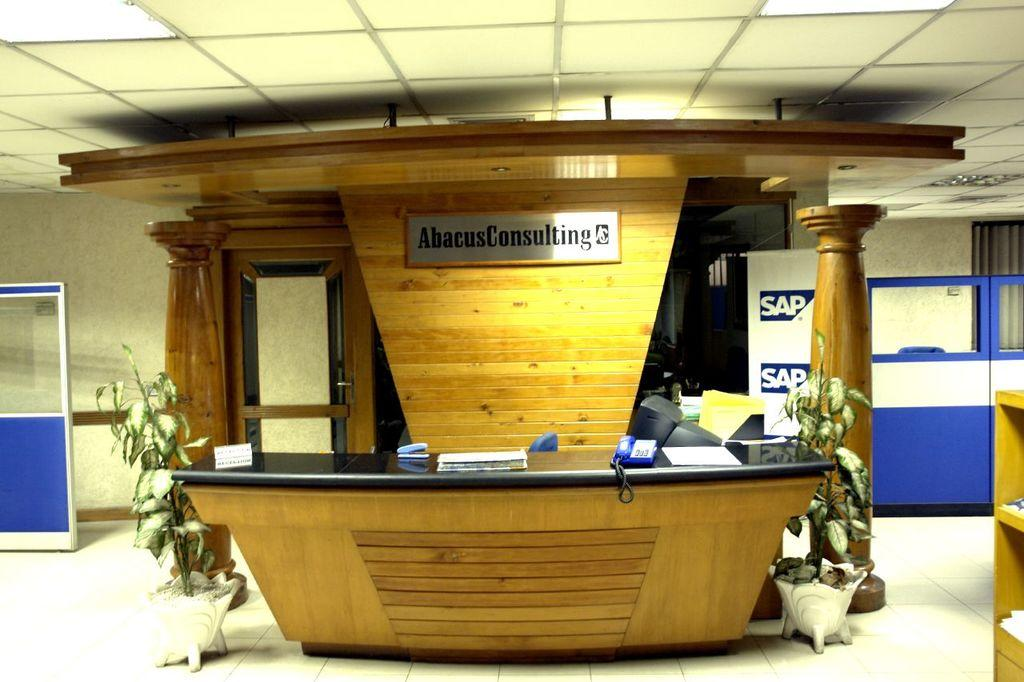How many plants can be seen in the image? There are 2 plants in the image. What is the main piece of furniture in the image? There is a table in the image. What electronic device is on the table? There is a monitor on the table. What is used to store items on the table? There is a rack on the table. What type of lighting is present in the image? There are lights on the ceiling. Is there a sofa in the image? No, there is no sofa present in the image. What position is the driver in the image? There is no driver or driving activity depicted in the image. 